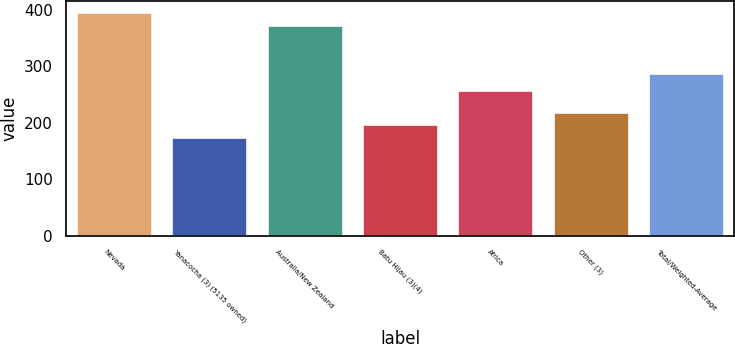<chart> <loc_0><loc_0><loc_500><loc_500><bar_chart><fcel>Nevada<fcel>Yanacocha (3) (5135 owned)<fcel>Australia/New Zealand<fcel>Batu Hijau (3)(4)<fcel>Africa<fcel>Other (3)<fcel>Total/Weighted-Average<nl><fcel>394.9<fcel>175<fcel>373<fcel>197<fcel>257<fcel>218.9<fcel>288<nl></chart> 